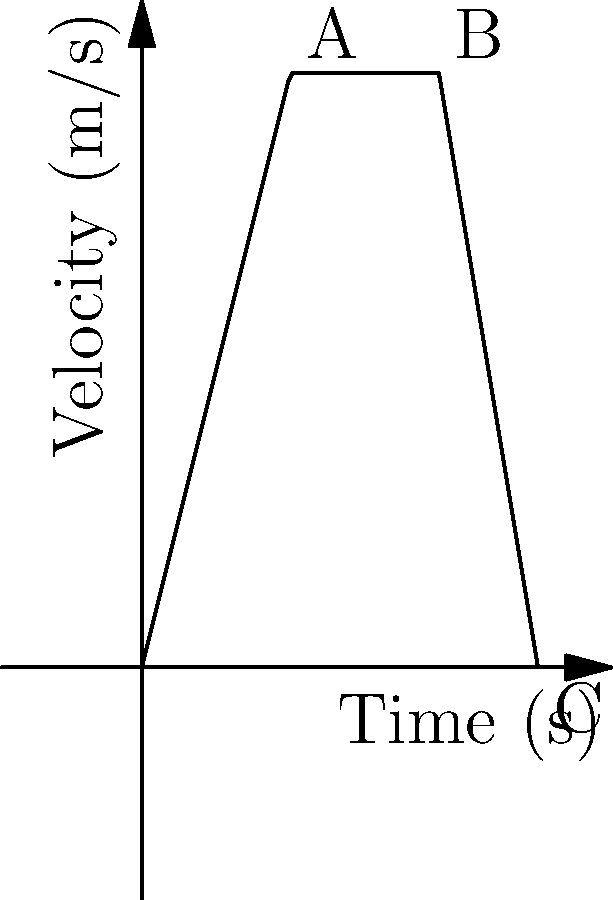As a taxi driver, you accelerate your vehicle from rest, maintain a constant speed, and then brake to a stop. The velocity-time graph of your journey is shown above. What is the total distance traveled during this trip? Let's break this down step-by-step:

1) The graph shows three phases: acceleration (0-5s), constant velocity (5-10s), and deceleration (10-13.33s).

2) To find the total distance, we need to calculate the area under the velocity-time graph.

3) For the acceleration phase (0-5s):
   Area = $\frac{1}{2} \times base \times height = \frac{1}{2} \times 5s \times 20m/s = 50m$

4) For the constant velocity phase (5-10s):
   Area = $base \times height = 5s \times 20m/s = 100m$

5) For the deceleration phase (10-13.33s):
   This is a triangle. 
   Base = $13.33s - 10s = 3.33s$
   Area = $\frac{1}{2} \times base \times height = \frac{1}{2} \times 3.33s \times 20m/s = 33.3m$

6) Total distance = Sum of all areas
   $50m + 100m + 33.3m = 183.3m$
Answer: 183.3 meters 